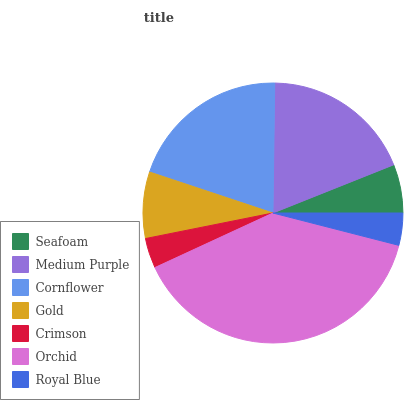Is Crimson the minimum?
Answer yes or no. Yes. Is Orchid the maximum?
Answer yes or no. Yes. Is Medium Purple the minimum?
Answer yes or no. No. Is Medium Purple the maximum?
Answer yes or no. No. Is Medium Purple greater than Seafoam?
Answer yes or no. Yes. Is Seafoam less than Medium Purple?
Answer yes or no. Yes. Is Seafoam greater than Medium Purple?
Answer yes or no. No. Is Medium Purple less than Seafoam?
Answer yes or no. No. Is Gold the high median?
Answer yes or no. Yes. Is Gold the low median?
Answer yes or no. Yes. Is Royal Blue the high median?
Answer yes or no. No. Is Seafoam the low median?
Answer yes or no. No. 